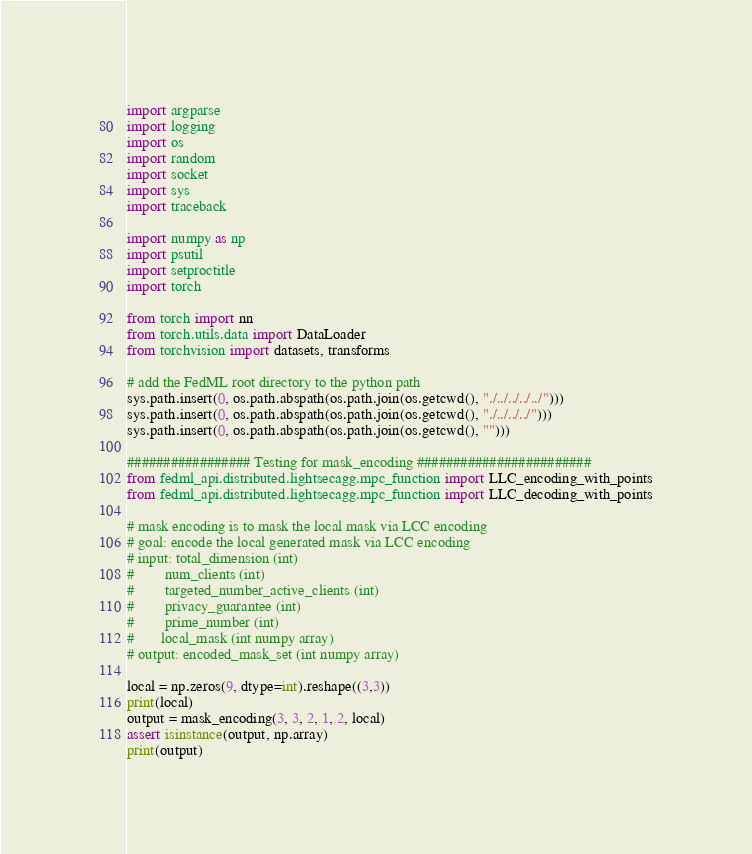Convert code to text. <code><loc_0><loc_0><loc_500><loc_500><_Python_>import argparse
import logging
import os
import random
import socket
import sys
import traceback

import numpy as np
import psutil
import setproctitle
import torch

from torch import nn
from torch.utils.data import DataLoader
from torchvision import datasets, transforms

# add the FedML root directory to the python path
sys.path.insert(0, os.path.abspath(os.path.join(os.getcwd(), "./../../../../")))
sys.path.insert(0, os.path.abspath(os.path.join(os.getcwd(), "./../../../")))
sys.path.insert(0, os.path.abspath(os.path.join(os.getcwd(), "")))

################# Testing for mask_encoding ########################
from fedml_api.distributed.lightsecagg.mpc_function import LLC_encoding_with_points
from fedml_api.distributed.lightsecagg.mpc_function import LLC_decoding_with_points

# mask encoding is to mask the local mask via LCC encoding
# goal: encode the local generated mask via LCC encoding
# input: total_dimension (int)
#        num_clients (int)
#        targeted_number_active_clients (int)
#        privacy_guarantee (int)
#        prime_number (int)
#       local_mask (int numpy array)
# output: encoded_mask_set (int numpy array)

local = np.zeros(9, dtype=int).reshape((3,3))
print(local)
output = mask_encoding(3, 3, 2, 1, 2, local)
assert isinstance(output, np.array)
print(output)
</code> 